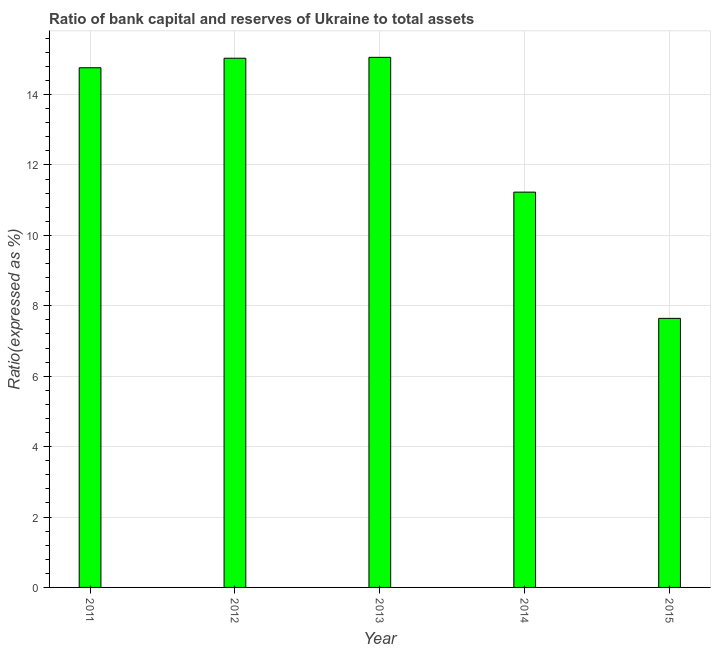Does the graph contain any zero values?
Provide a succinct answer. No. Does the graph contain grids?
Keep it short and to the point. Yes. What is the title of the graph?
Your response must be concise. Ratio of bank capital and reserves of Ukraine to total assets. What is the label or title of the X-axis?
Give a very brief answer. Year. What is the label or title of the Y-axis?
Offer a very short reply. Ratio(expressed as %). What is the bank capital to assets ratio in 2013?
Your answer should be very brief. 15.06. Across all years, what is the maximum bank capital to assets ratio?
Provide a short and direct response. 15.06. Across all years, what is the minimum bank capital to assets ratio?
Ensure brevity in your answer.  7.64. In which year was the bank capital to assets ratio minimum?
Give a very brief answer. 2015. What is the sum of the bank capital to assets ratio?
Provide a short and direct response. 63.72. What is the difference between the bank capital to assets ratio in 2012 and 2015?
Your answer should be compact. 7.39. What is the average bank capital to assets ratio per year?
Make the answer very short. 12.74. What is the median bank capital to assets ratio?
Ensure brevity in your answer.  14.76. In how many years, is the bank capital to assets ratio greater than 15.2 %?
Provide a succinct answer. 0. What is the ratio of the bank capital to assets ratio in 2011 to that in 2012?
Ensure brevity in your answer.  0.98. Is the bank capital to assets ratio in 2012 less than that in 2015?
Offer a terse response. No. What is the difference between the highest and the second highest bank capital to assets ratio?
Your answer should be compact. 0.03. Is the sum of the bank capital to assets ratio in 2011 and 2014 greater than the maximum bank capital to assets ratio across all years?
Give a very brief answer. Yes. What is the difference between the highest and the lowest bank capital to assets ratio?
Offer a terse response. 7.41. In how many years, is the bank capital to assets ratio greater than the average bank capital to assets ratio taken over all years?
Your response must be concise. 3. How many bars are there?
Your answer should be very brief. 5. Are all the bars in the graph horizontal?
Ensure brevity in your answer.  No. Are the values on the major ticks of Y-axis written in scientific E-notation?
Provide a succinct answer. No. What is the Ratio(expressed as %) in 2011?
Keep it short and to the point. 14.76. What is the Ratio(expressed as %) in 2012?
Give a very brief answer. 15.03. What is the Ratio(expressed as %) in 2013?
Ensure brevity in your answer.  15.06. What is the Ratio(expressed as %) in 2014?
Your answer should be compact. 11.23. What is the Ratio(expressed as %) of 2015?
Offer a very short reply. 7.64. What is the difference between the Ratio(expressed as %) in 2011 and 2012?
Offer a terse response. -0.27. What is the difference between the Ratio(expressed as %) in 2011 and 2013?
Ensure brevity in your answer.  -0.3. What is the difference between the Ratio(expressed as %) in 2011 and 2014?
Provide a succinct answer. 3.53. What is the difference between the Ratio(expressed as %) in 2011 and 2015?
Your answer should be compact. 7.12. What is the difference between the Ratio(expressed as %) in 2012 and 2013?
Give a very brief answer. -0.03. What is the difference between the Ratio(expressed as %) in 2012 and 2014?
Your answer should be very brief. 3.8. What is the difference between the Ratio(expressed as %) in 2012 and 2015?
Provide a short and direct response. 7.39. What is the difference between the Ratio(expressed as %) in 2013 and 2014?
Provide a succinct answer. 3.83. What is the difference between the Ratio(expressed as %) in 2013 and 2015?
Your answer should be compact. 7.41. What is the difference between the Ratio(expressed as %) in 2014 and 2015?
Your answer should be compact. 3.59. What is the ratio of the Ratio(expressed as %) in 2011 to that in 2012?
Keep it short and to the point. 0.98. What is the ratio of the Ratio(expressed as %) in 2011 to that in 2013?
Your response must be concise. 0.98. What is the ratio of the Ratio(expressed as %) in 2011 to that in 2014?
Ensure brevity in your answer.  1.31. What is the ratio of the Ratio(expressed as %) in 2011 to that in 2015?
Provide a short and direct response. 1.93. What is the ratio of the Ratio(expressed as %) in 2012 to that in 2013?
Offer a terse response. 1. What is the ratio of the Ratio(expressed as %) in 2012 to that in 2014?
Offer a very short reply. 1.34. What is the ratio of the Ratio(expressed as %) in 2012 to that in 2015?
Give a very brief answer. 1.97. What is the ratio of the Ratio(expressed as %) in 2013 to that in 2014?
Your response must be concise. 1.34. What is the ratio of the Ratio(expressed as %) in 2013 to that in 2015?
Provide a succinct answer. 1.97. What is the ratio of the Ratio(expressed as %) in 2014 to that in 2015?
Provide a short and direct response. 1.47. 